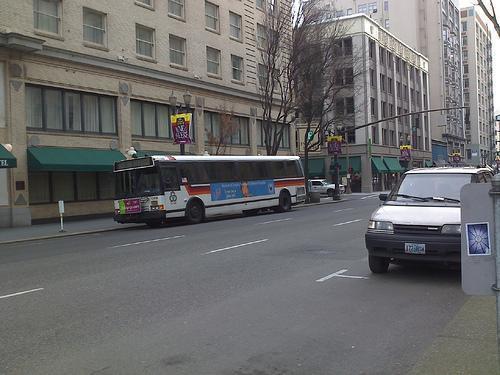How many buses are in the photo?
Give a very brief answer. 1. 